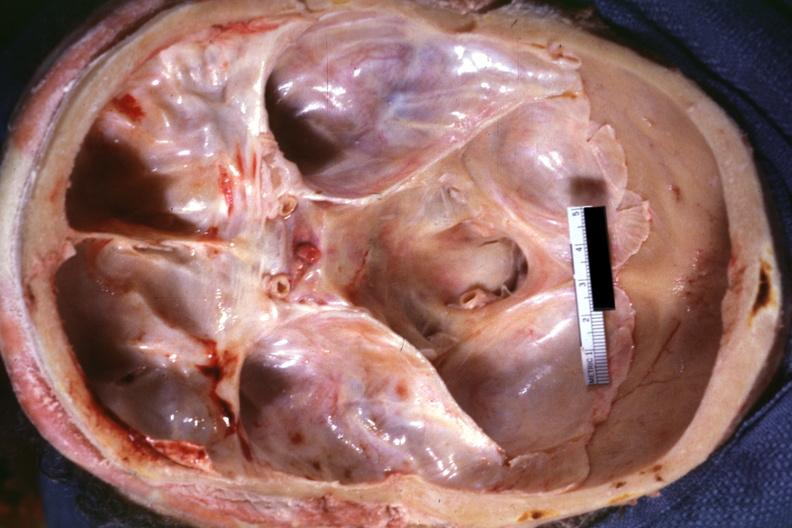what is present?
Answer the question using a single word or phrase. Odontoid process subluxation with narrowing of foramen magnum 